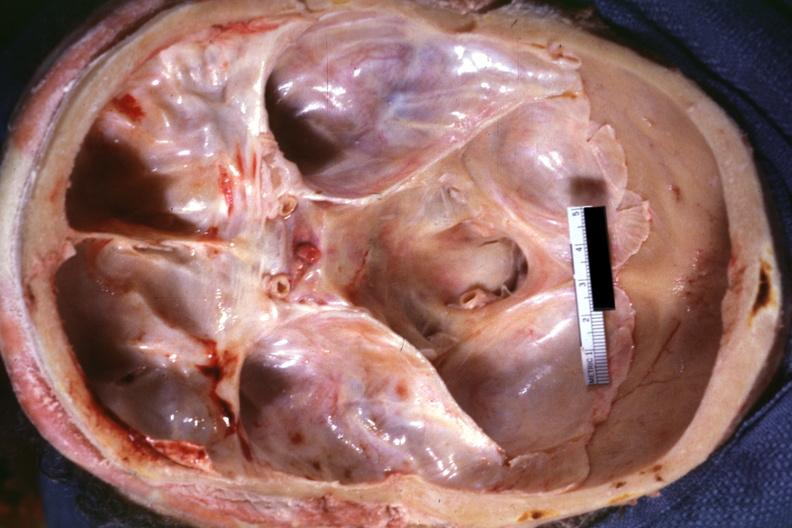what is present?
Answer the question using a single word or phrase. Odontoid process subluxation with narrowing of foramen magnum 